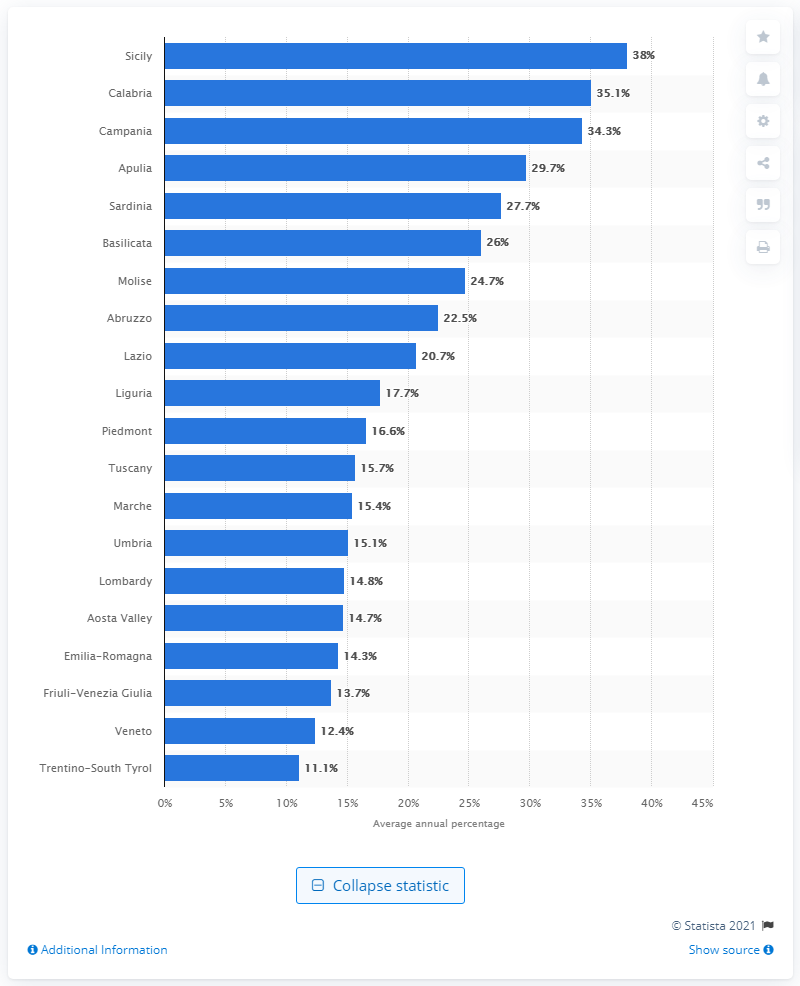Specify some key components in this picture. The region of Trentino-South Tyrol had the lowest percentage of NEET individuals among all the regions studied. In 2019, the percentage of young people who were not in education, employment, or training peaked in Sicily, specifically in Sicily. 